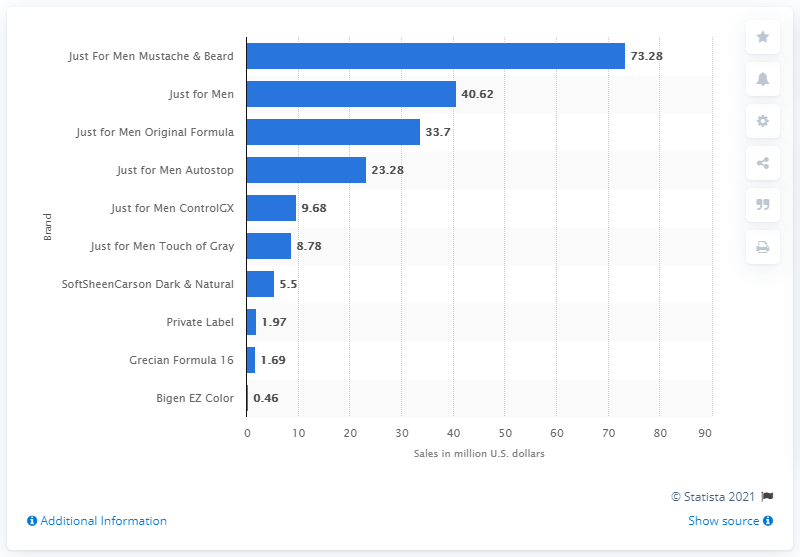Identify some key points in this picture. In the year 2020, the most popular brand of hair coloring for men in the United States was Just For Men Mustache & Beard. In the United States in 2020, the Just For Men Mustache & Beard product line generated approximately $73.28 million in revenue. In 2020, the sales of the Just for Men hair coloring brand in the United States were approximately 40.62 million dollars. 